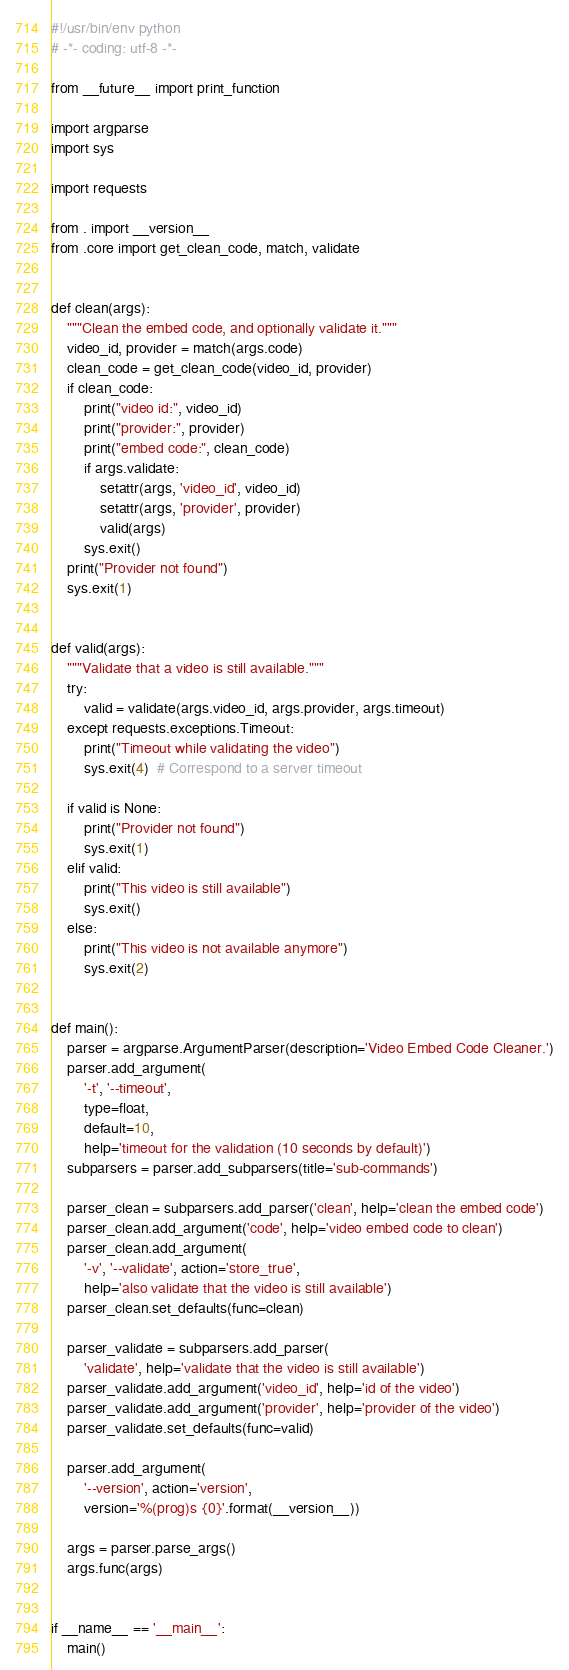Convert code to text. <code><loc_0><loc_0><loc_500><loc_500><_Python_>#!/usr/bin/env python
# -*- coding: utf-8 -*-

from __future__ import print_function

import argparse
import sys

import requests

from . import __version__
from .core import get_clean_code, match, validate


def clean(args):
    """Clean the embed code, and optionally validate it."""
    video_id, provider = match(args.code)
    clean_code = get_clean_code(video_id, provider)
    if clean_code:
        print("video id:", video_id)
        print("provider:", provider)
        print("embed code:", clean_code)
        if args.validate:
            setattr(args, 'video_id', video_id)
            setattr(args, 'provider', provider)
            valid(args)
        sys.exit()
    print("Provider not found")
    sys.exit(1)


def valid(args):
    """Validate that a video is still available."""
    try:
        valid = validate(args.video_id, args.provider, args.timeout)
    except requests.exceptions.Timeout:
        print("Timeout while validating the video")
        sys.exit(4)  # Correspond to a server timeout

    if valid is None:
        print("Provider not found")
        sys.exit(1)
    elif valid:
        print("This video is still available")
        sys.exit()
    else:
        print("This video is not available anymore")
        sys.exit(2)


def main():
    parser = argparse.ArgumentParser(description='Video Embed Code Cleaner.')
    parser.add_argument(
        '-t', '--timeout',
        type=float,
        default=10,
        help='timeout for the validation (10 seconds by default)')
    subparsers = parser.add_subparsers(title='sub-commands')

    parser_clean = subparsers.add_parser('clean', help='clean the embed code')
    parser_clean.add_argument('code', help='video embed code to clean')
    parser_clean.add_argument(
        '-v', '--validate', action='store_true',
        help='also validate that the video is still available')
    parser_clean.set_defaults(func=clean)

    parser_validate = subparsers.add_parser(
        'validate', help='validate that the video is still available')
    parser_validate.add_argument('video_id', help='id of the video')
    parser_validate.add_argument('provider', help='provider of the video')
    parser_validate.set_defaults(func=valid)

    parser.add_argument(
        '--version', action='version',
        version='%(prog)s {0}'.format(__version__))

    args = parser.parse_args()
    args.func(args)


if __name__ == '__main__':
    main()
</code> 